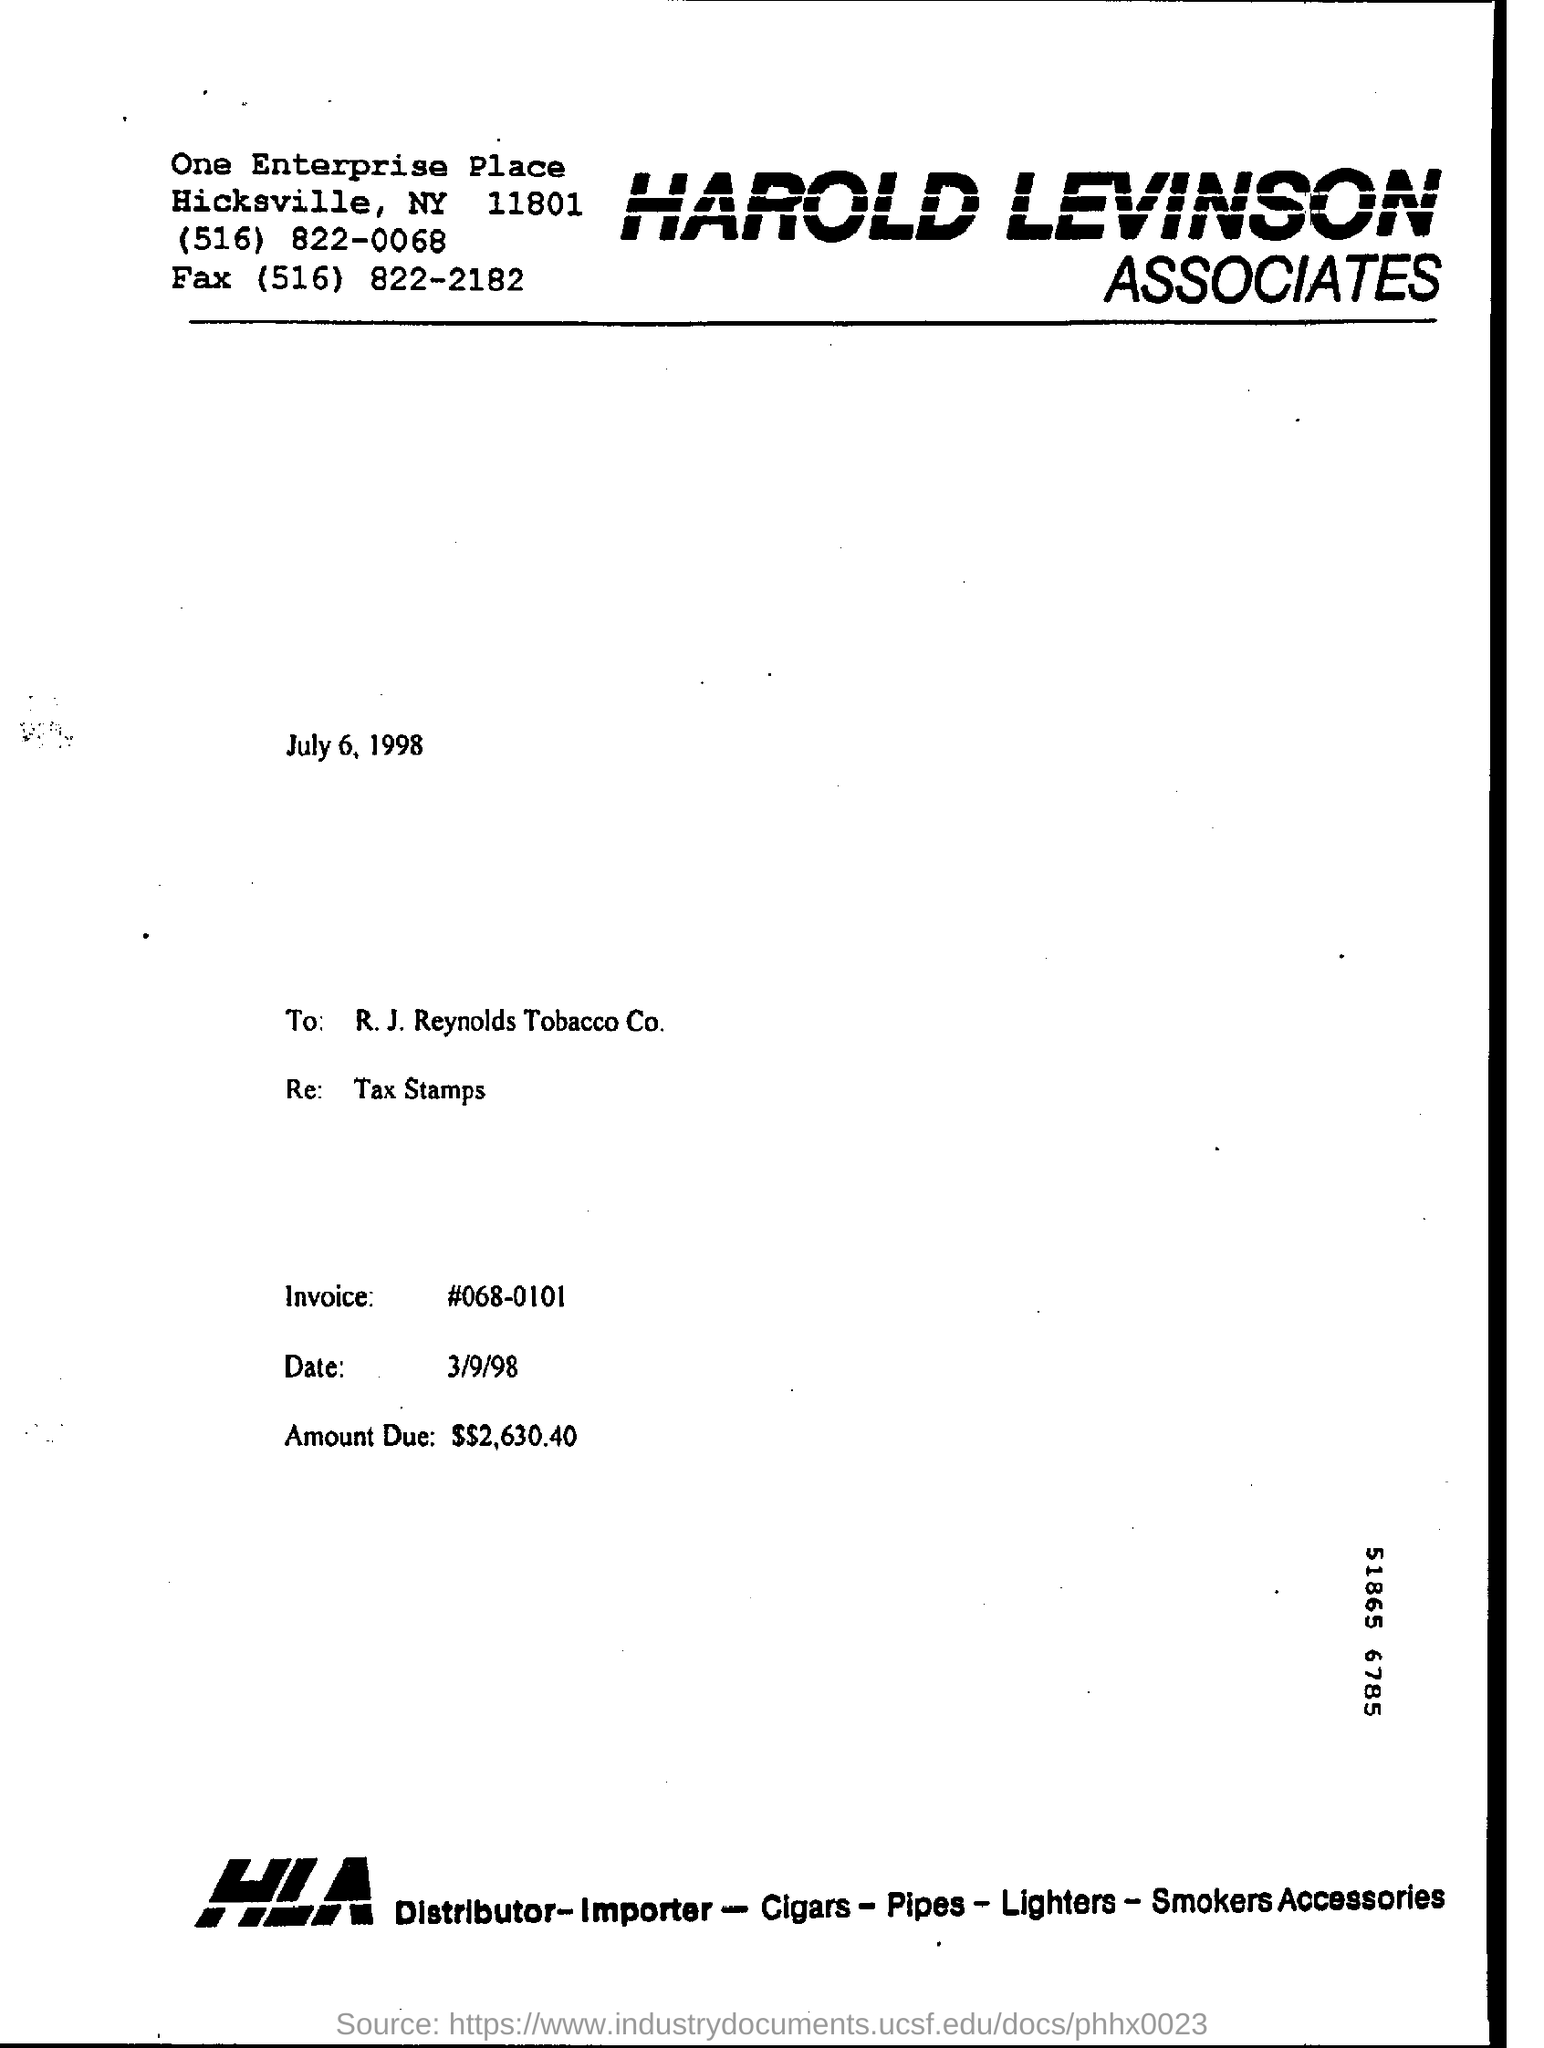List a handful of essential elements in this visual. The invoice number displayed on the page is #068-0101. 